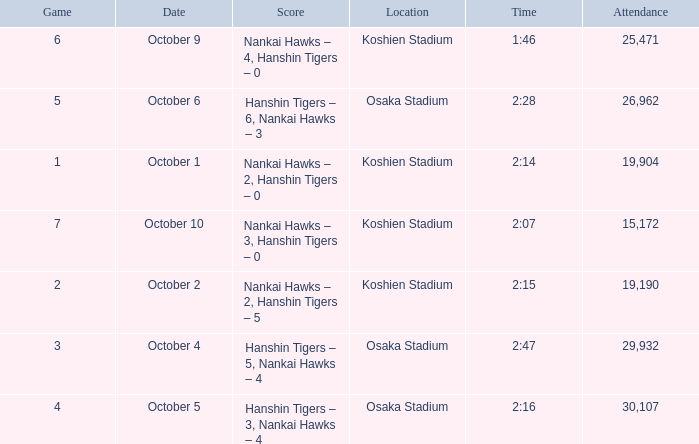Which Score has a Time of 2:28? Hanshin Tigers – 6, Nankai Hawks – 3. Write the full table. {'header': ['Game', 'Date', 'Score', 'Location', 'Time', 'Attendance'], 'rows': [['6', 'October 9', 'Nankai Hawks – 4, Hanshin Tigers – 0', 'Koshien Stadium', '1:46', '25,471'], ['5', 'October 6', 'Hanshin Tigers – 6, Nankai Hawks – 3', 'Osaka Stadium', '2:28', '26,962'], ['1', 'October 1', 'Nankai Hawks – 2, Hanshin Tigers – 0', 'Koshien Stadium', '2:14', '19,904'], ['7', 'October 10', 'Nankai Hawks – 3, Hanshin Tigers – 0', 'Koshien Stadium', '2:07', '15,172'], ['2', 'October 2', 'Nankai Hawks – 2, Hanshin Tigers – 5', 'Koshien Stadium', '2:15', '19,190'], ['3', 'October 4', 'Hanshin Tigers – 5, Nankai Hawks – 4', 'Osaka Stadium', '2:47', '29,932'], ['4', 'October 5', 'Hanshin Tigers – 3, Nankai Hawks – 4', 'Osaka Stadium', '2:16', '30,107']]} 